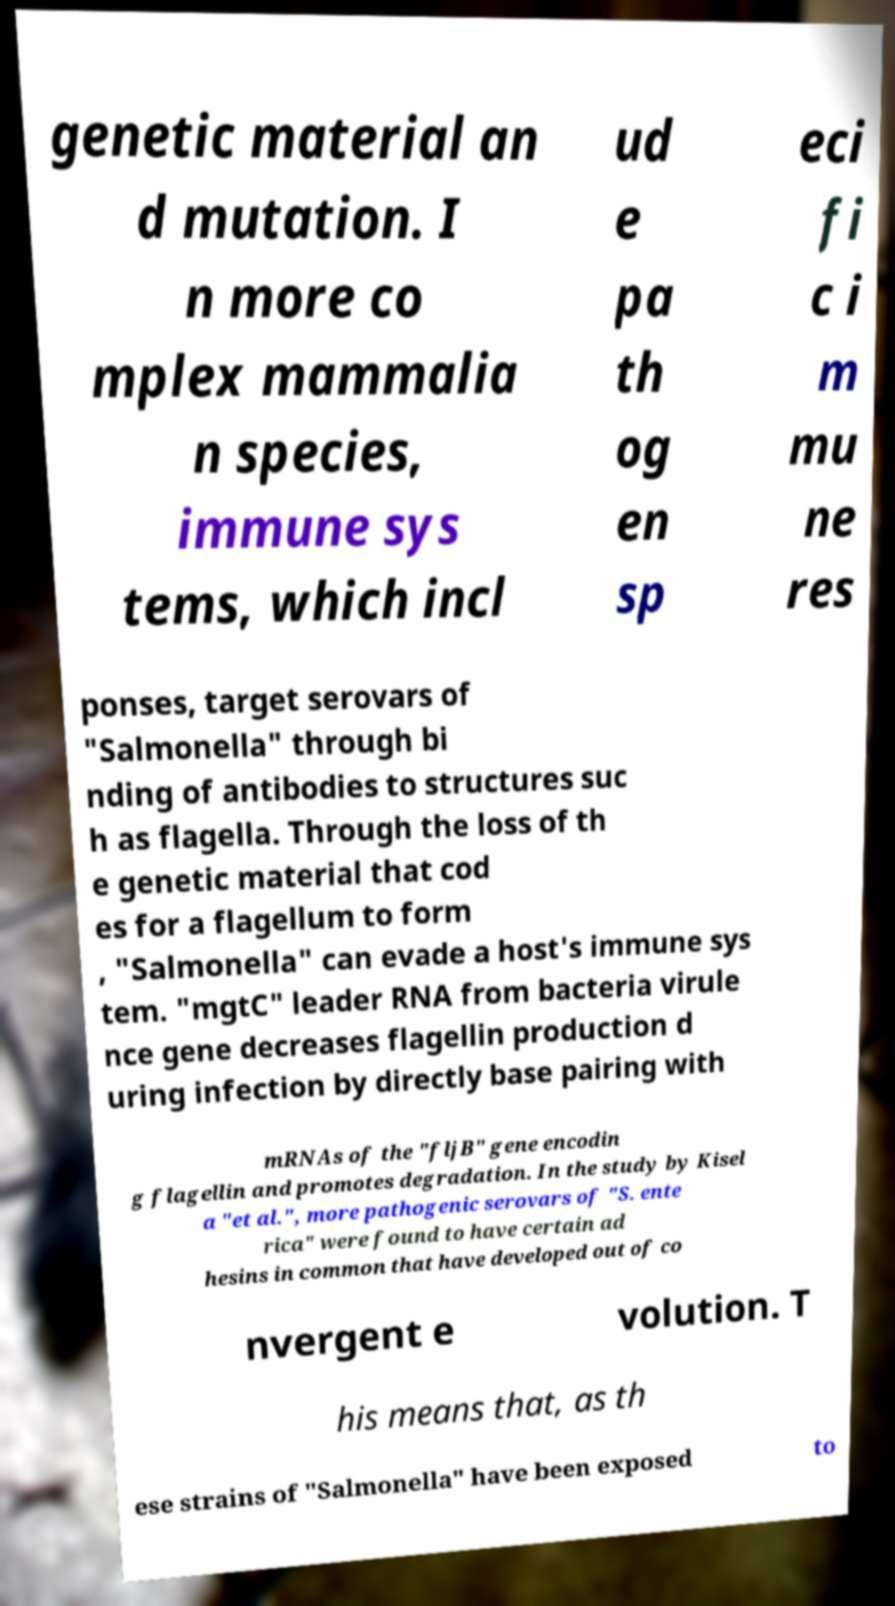There's text embedded in this image that I need extracted. Can you transcribe it verbatim? genetic material an d mutation. I n more co mplex mammalia n species, immune sys tems, which incl ud e pa th og en sp eci fi c i m mu ne res ponses, target serovars of "Salmonella" through bi nding of antibodies to structures suc h as flagella. Through the loss of th e genetic material that cod es for a flagellum to form , "Salmonella" can evade a host's immune sys tem. "mgtC" leader RNA from bacteria virule nce gene decreases flagellin production d uring infection by directly base pairing with mRNAs of the "fljB" gene encodin g flagellin and promotes degradation. In the study by Kisel a "et al.", more pathogenic serovars of "S. ente rica" were found to have certain ad hesins in common that have developed out of co nvergent e volution. T his means that, as th ese strains of "Salmonella" have been exposed to 